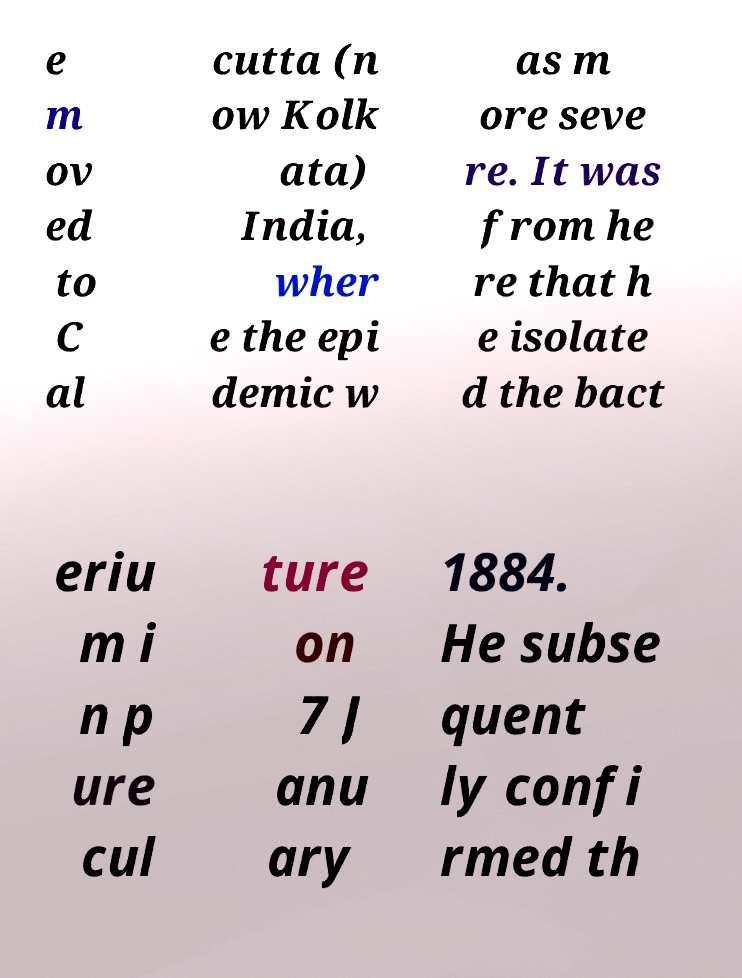Could you extract and type out the text from this image? e m ov ed to C al cutta (n ow Kolk ata) India, wher e the epi demic w as m ore seve re. It was from he re that h e isolate d the bact eriu m i n p ure cul ture on 7 J anu ary 1884. He subse quent ly confi rmed th 